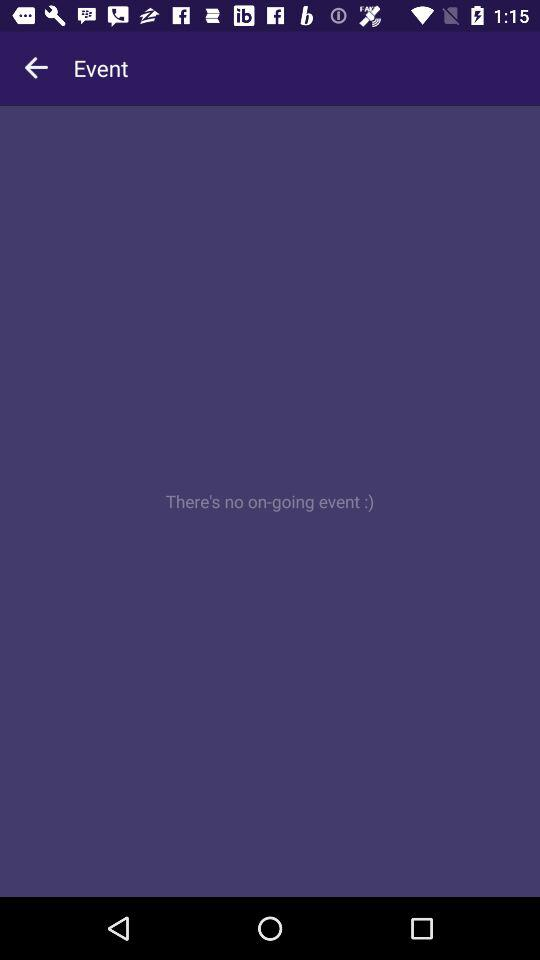How many ongoing events are there? There are no ongoing events. 